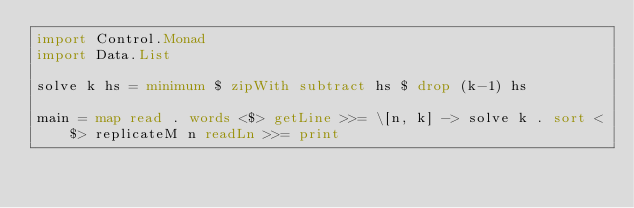Convert code to text. <code><loc_0><loc_0><loc_500><loc_500><_Haskell_>import Control.Monad
import Data.List

solve k hs = minimum $ zipWith subtract hs $ drop (k-1) hs

main = map read . words <$> getLine >>= \[n, k] -> solve k . sort <$> replicateM n readLn >>= print</code> 